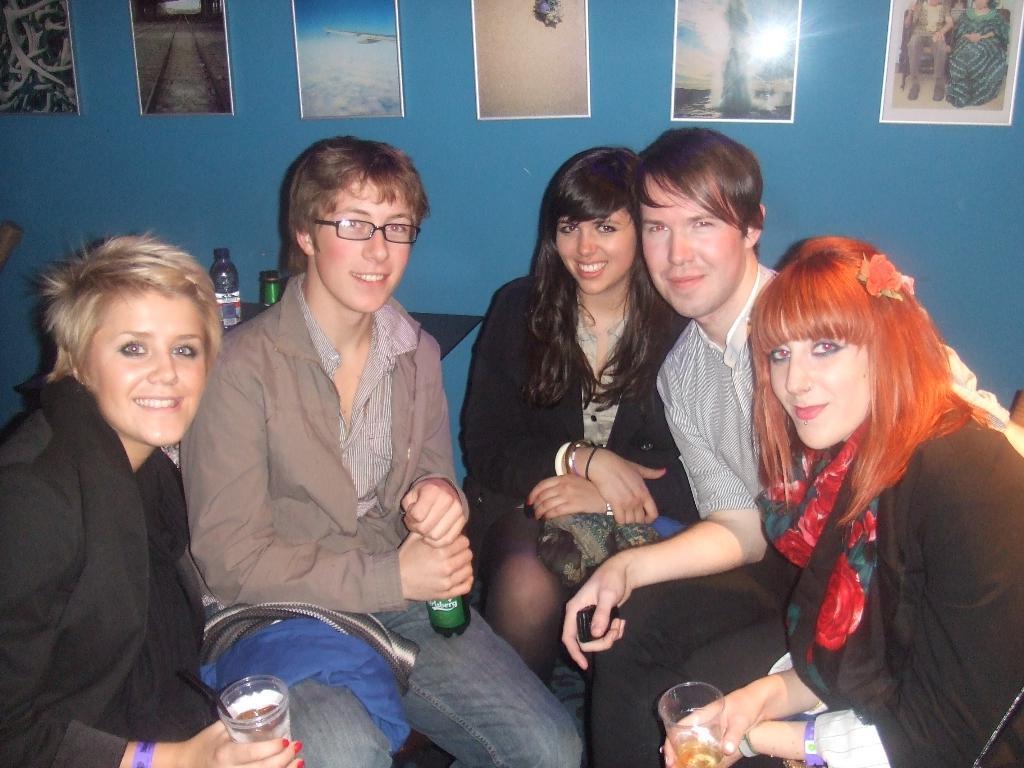In one or two sentences, can you explain what this image depicts? In this image I can see number of people are sitting, I can also see smile on their faces. In the front of this image I can see two women are holding glasses and in the centre I can see one of them is holding a bottle. In the background I can see blue colour wall and on it I can see number of frames. I can also a bottle and a green colour thing in the background. 